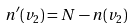Convert formula to latex. <formula><loc_0><loc_0><loc_500><loc_500>n ^ { \prime } ( v _ { 2 } ) = N - n ( v _ { 2 } )</formula> 